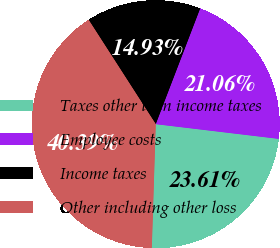Convert chart. <chart><loc_0><loc_0><loc_500><loc_500><pie_chart><fcel>Taxes other than income taxes<fcel>Employee costs<fcel>Income taxes<fcel>Other including other loss<nl><fcel>23.61%<fcel>21.06%<fcel>14.93%<fcel>40.39%<nl></chart> 